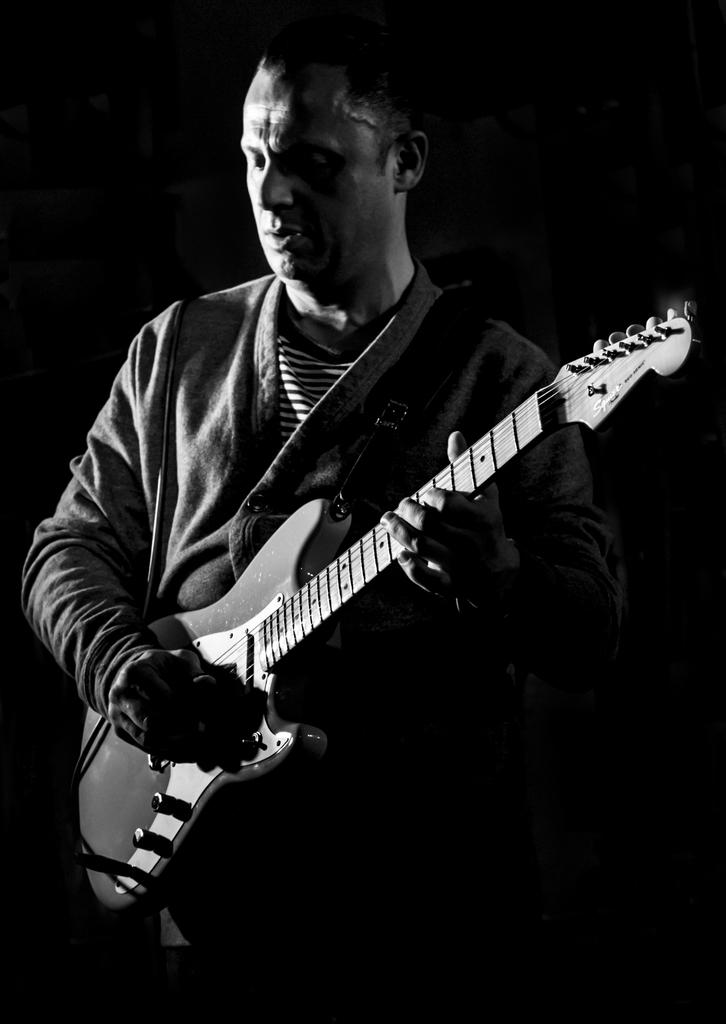What is the main subject of the image? There is a man in the image. What is the man doing in the image? The man is standing in the image. What object is the man holding in his hands? The man is holding a guitar in his hands. What type of memory is the man trying to recall while holding the guitar in the image? There is no indication in the image that the man is trying to recall any memory. 